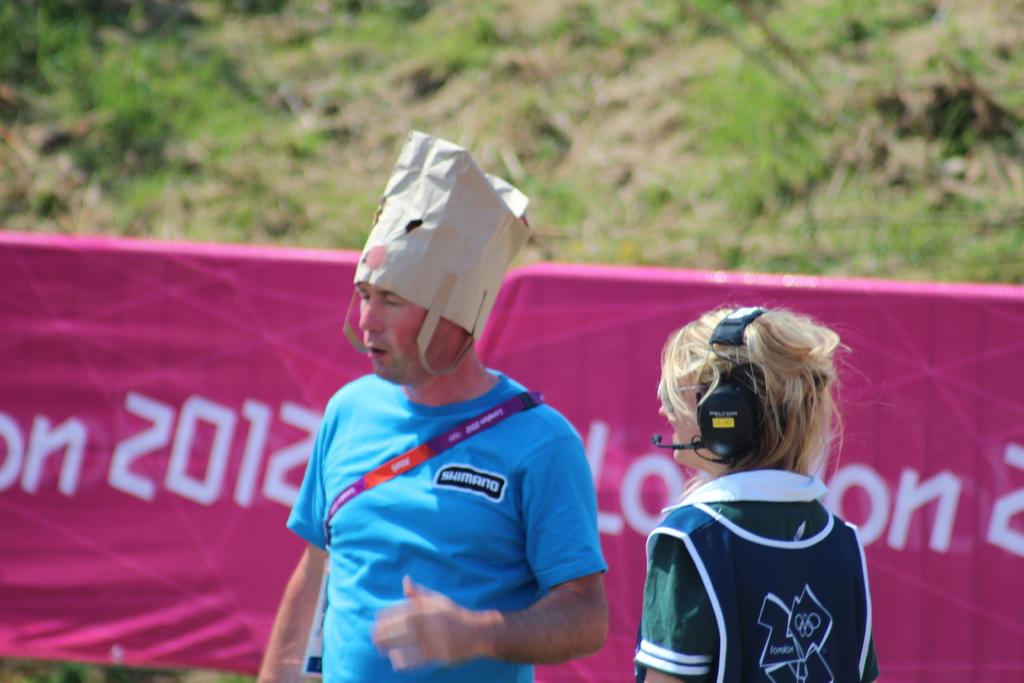What year is listed on the pink banner?
Make the answer very short. 2012. 